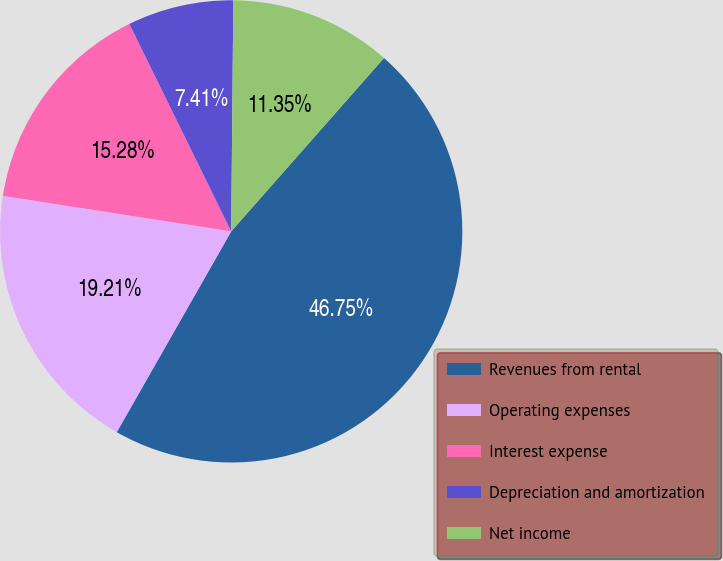Convert chart. <chart><loc_0><loc_0><loc_500><loc_500><pie_chart><fcel>Revenues from rental<fcel>Operating expenses<fcel>Interest expense<fcel>Depreciation and amortization<fcel>Net income<nl><fcel>46.75%<fcel>19.21%<fcel>15.28%<fcel>7.41%<fcel>11.35%<nl></chart> 